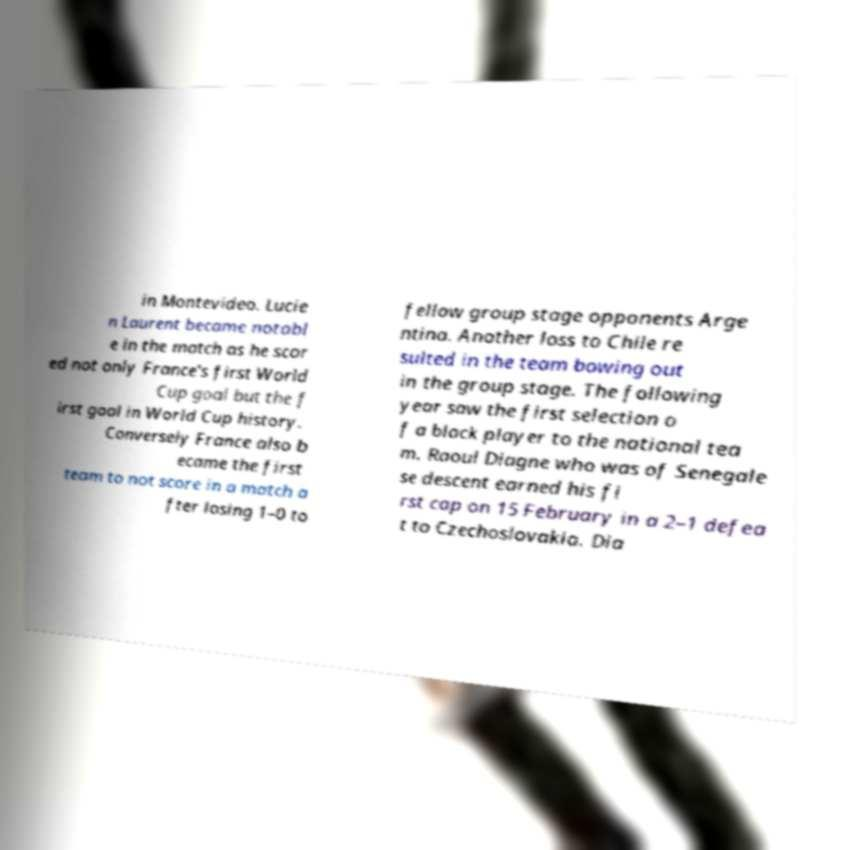There's text embedded in this image that I need extracted. Can you transcribe it verbatim? in Montevideo. Lucie n Laurent became notabl e in the match as he scor ed not only France's first World Cup goal but the f irst goal in World Cup history. Conversely France also b ecame the first team to not score in a match a fter losing 1–0 to fellow group stage opponents Arge ntina. Another loss to Chile re sulted in the team bowing out in the group stage. The following year saw the first selection o f a black player to the national tea m. Raoul Diagne who was of Senegale se descent earned his fi rst cap on 15 February in a 2–1 defea t to Czechoslovakia. Dia 